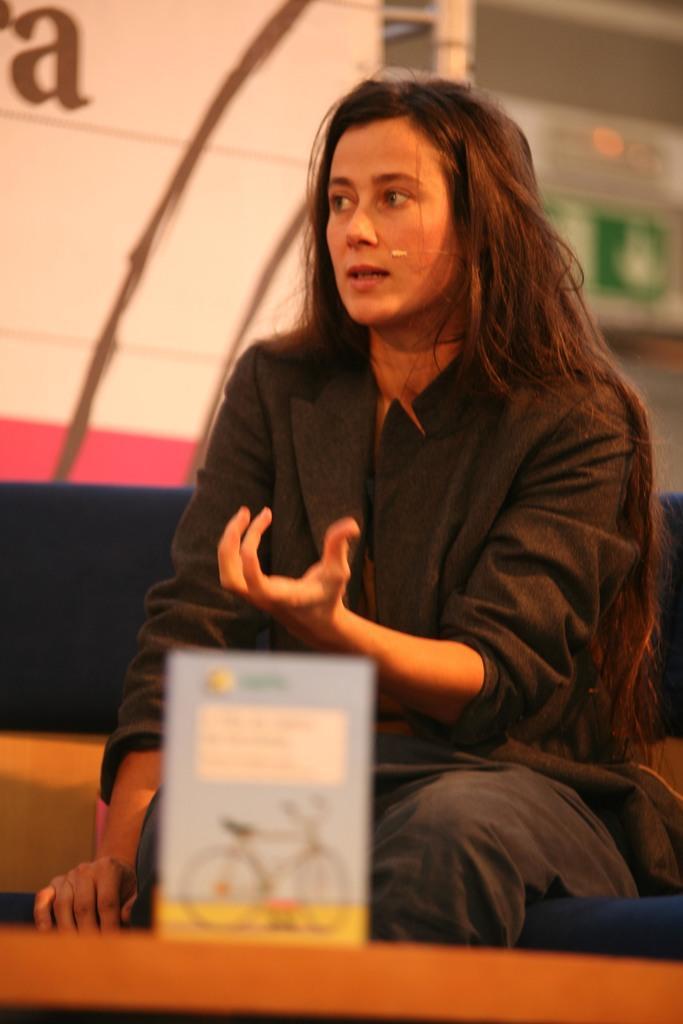Could you give a brief overview of what you see in this image? In this image I can see a woman sitting wearing black dress. Front I can see a board which is in blue and yellow color. Back I can see a white and pink color. 